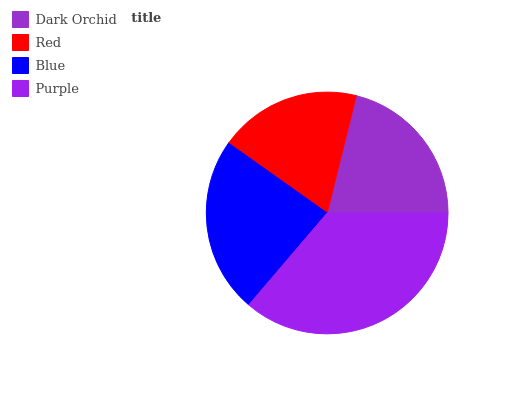Is Red the minimum?
Answer yes or no. Yes. Is Purple the maximum?
Answer yes or no. Yes. Is Blue the minimum?
Answer yes or no. No. Is Blue the maximum?
Answer yes or no. No. Is Blue greater than Red?
Answer yes or no. Yes. Is Red less than Blue?
Answer yes or no. Yes. Is Red greater than Blue?
Answer yes or no. No. Is Blue less than Red?
Answer yes or no. No. Is Blue the high median?
Answer yes or no. Yes. Is Dark Orchid the low median?
Answer yes or no. Yes. Is Purple the high median?
Answer yes or no. No. Is Red the low median?
Answer yes or no. No. 